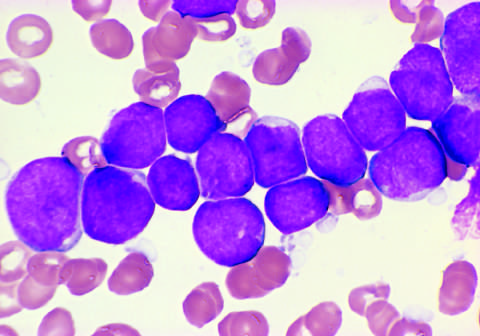what are positive for the b cell markers cd19 and cd22?
Answer the question using a single word or phrase. The tumor cells 